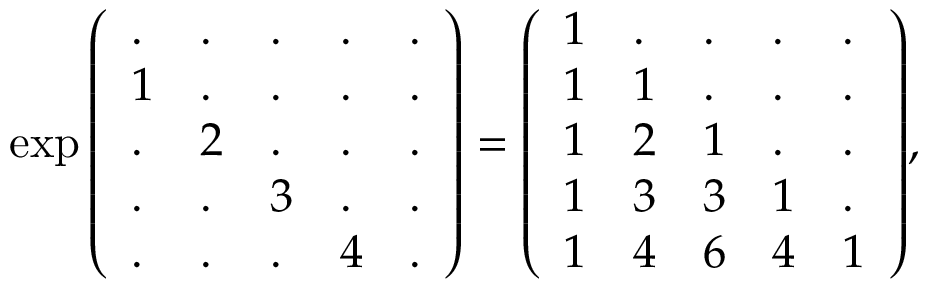<formula> <loc_0><loc_0><loc_500><loc_500>\exp { \left ( \begin{array} { l l l l l } { . } & { . } & { . } & { . } & { . } \\ { 1 } & { . } & { . } & { . } & { . } \\ { . } & { 2 } & { . } & { . } & { . } \\ { . } & { . } & { 3 } & { . } & { . } \\ { . } & { . } & { . } & { 4 } & { . } \end{array} \right ) } = { \left ( \begin{array} { l l l l l } { 1 } & { . } & { . } & { . } & { . } \\ { 1 } & { 1 } & { . } & { . } & { . } \\ { 1 } & { 2 } & { 1 } & { . } & { . } \\ { 1 } & { 3 } & { 3 } & { 1 } & { . } \\ { 1 } & { 4 } & { 6 } & { 4 } & { 1 } \end{array} \right ) } ,</formula> 